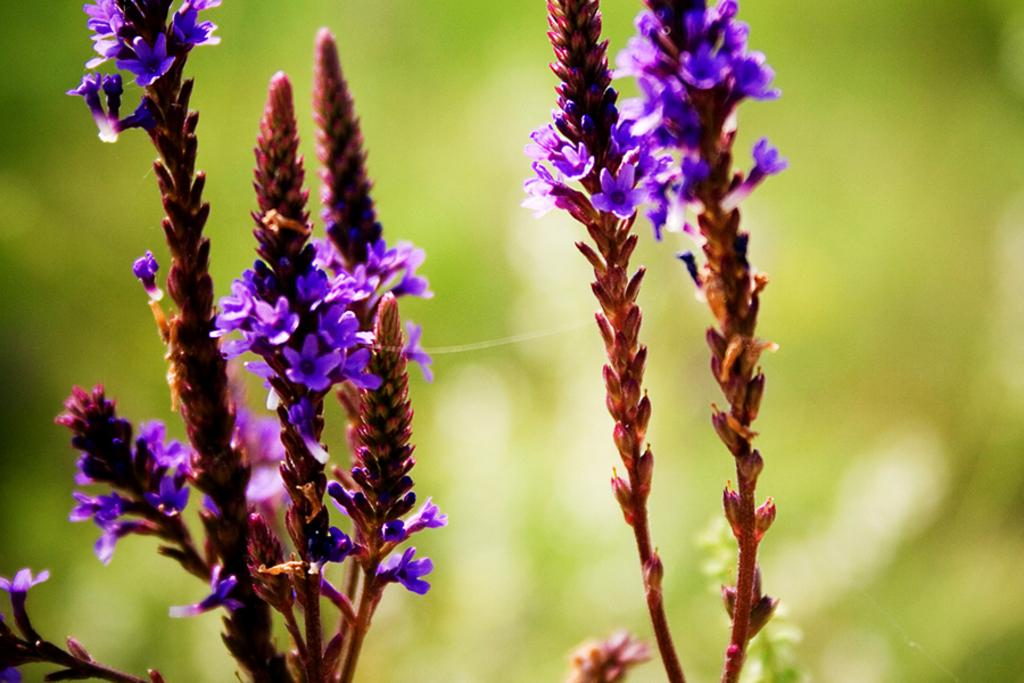What type of living organisms can be seen in the image? Plants can be seen in the image. What is the color of the plants in the image? The plants are brown in color. What additional features can be observed on the plants? There are flowers on the plants. What is the color of the flowers on the plants? The flowers are purple in color. Can you describe the background of the image? The background of the image is green and blurry. What religious symbol can be seen in the image? There is no religious symbol present in the image. What type of fiction is being depicted in the image? The image does not depict any fiction; it features plants with flowers. 